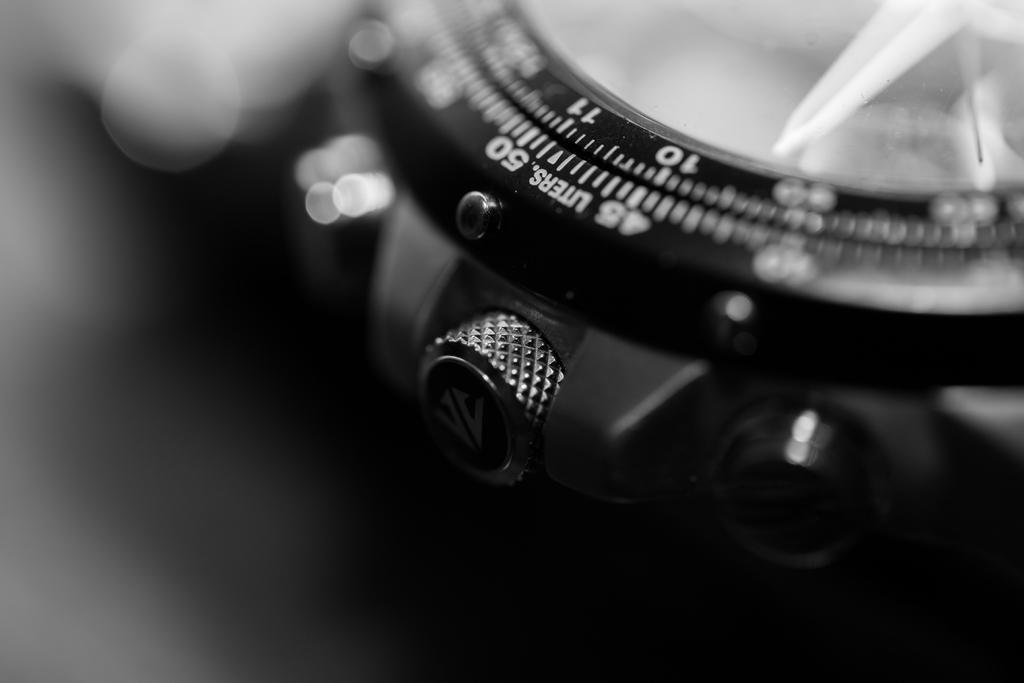Please provide a concise description of this image. In this image I see a watch over here on which there are numbers and I see word written over here and I see that it is blurred in the background. 